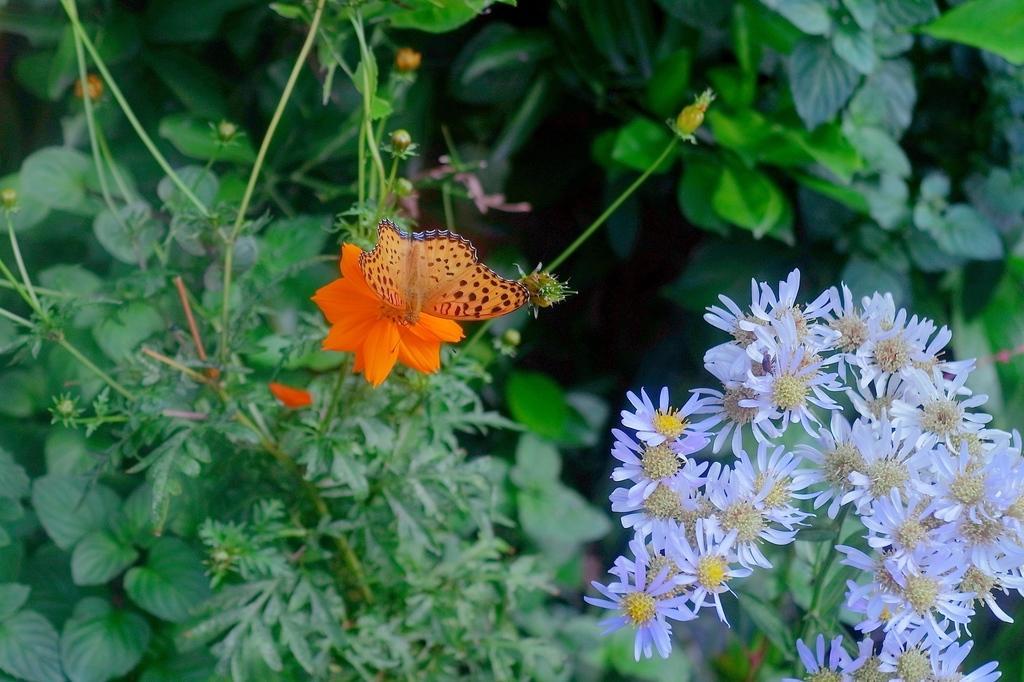How would you summarize this image in a sentence or two? In the picture I can see the flowering plants and green leaves. I can see a flying insect on the flower. 